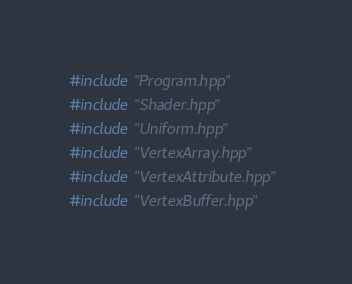Convert code to text. <code><loc_0><loc_0><loc_500><loc_500><_C++_>#include "Program.hpp"
#include "Shader.hpp"
#include "Uniform.hpp"
#include "VertexArray.hpp"
#include "VertexAttribute.hpp"
#include "VertexBuffer.hpp"</code> 